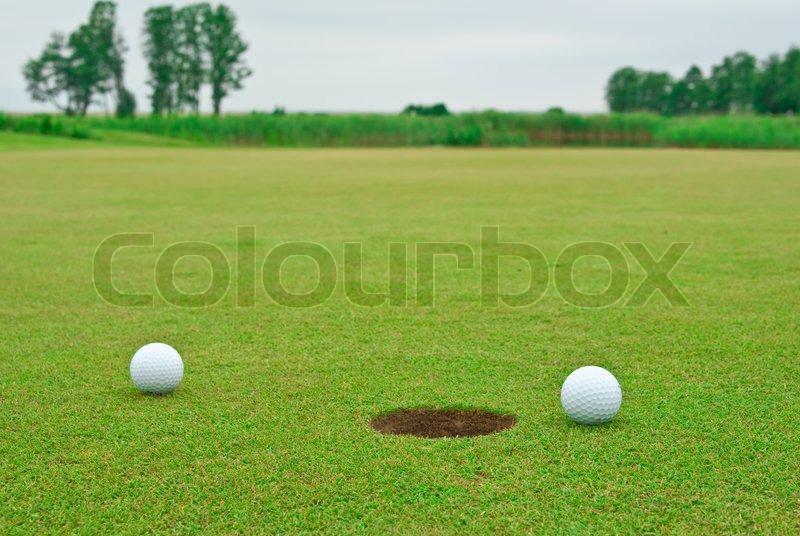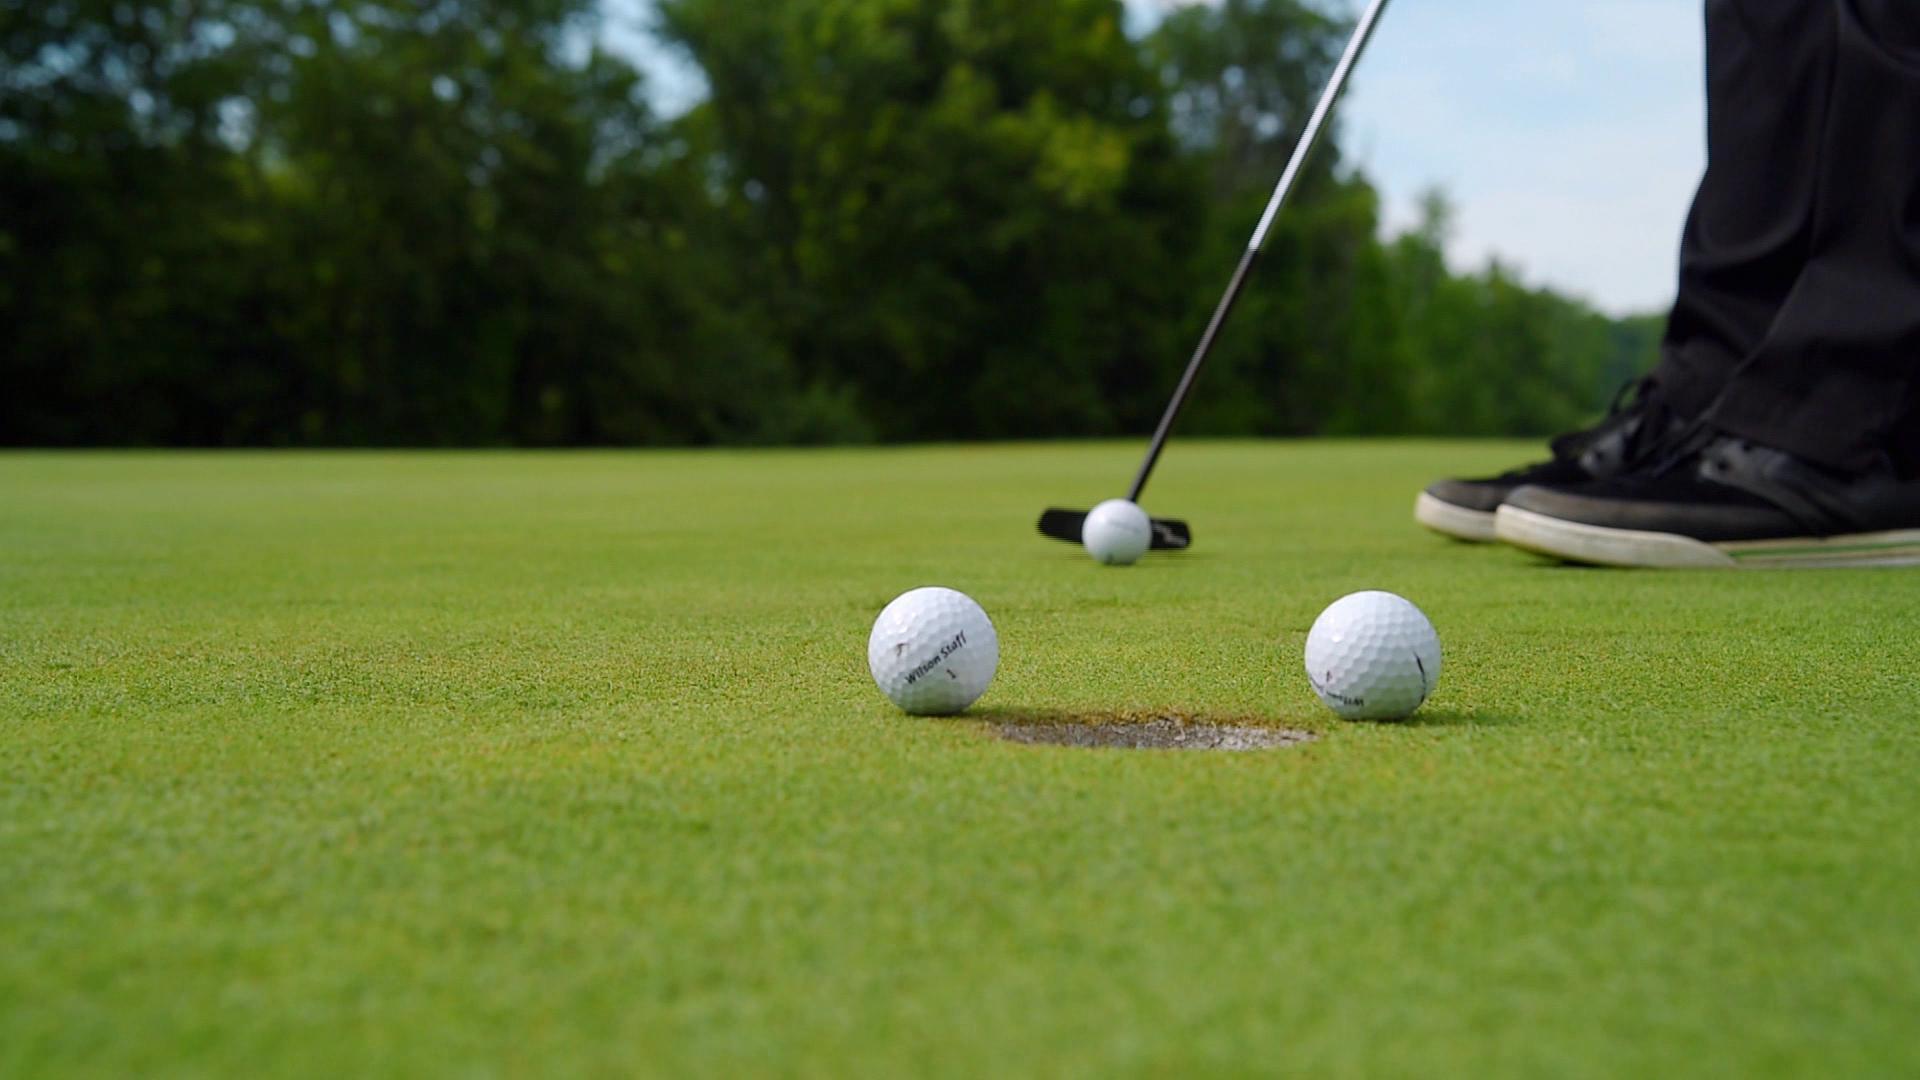The first image is the image on the left, the second image is the image on the right. Assess this claim about the two images: "In the right image, a single golf ball on a tee and part of a golf club are visible". Correct or not? Answer yes or no. No. 